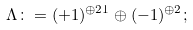<formula> <loc_0><loc_0><loc_500><loc_500>\Lambda \colon = ( + 1 ) ^ { \oplus 2 1 } \oplus ( - 1 ) ^ { \oplus 2 } ;</formula> 